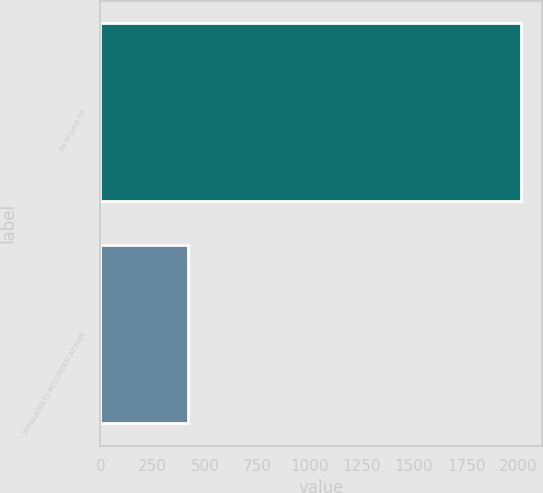Convert chart to OTSL. <chart><loc_0><loc_0><loc_500><loc_500><bar_chart><fcel>As of June 30<fcel>TOTALASSETS RECORDED AT FAIR<nl><fcel>2012<fcel>419<nl></chart> 